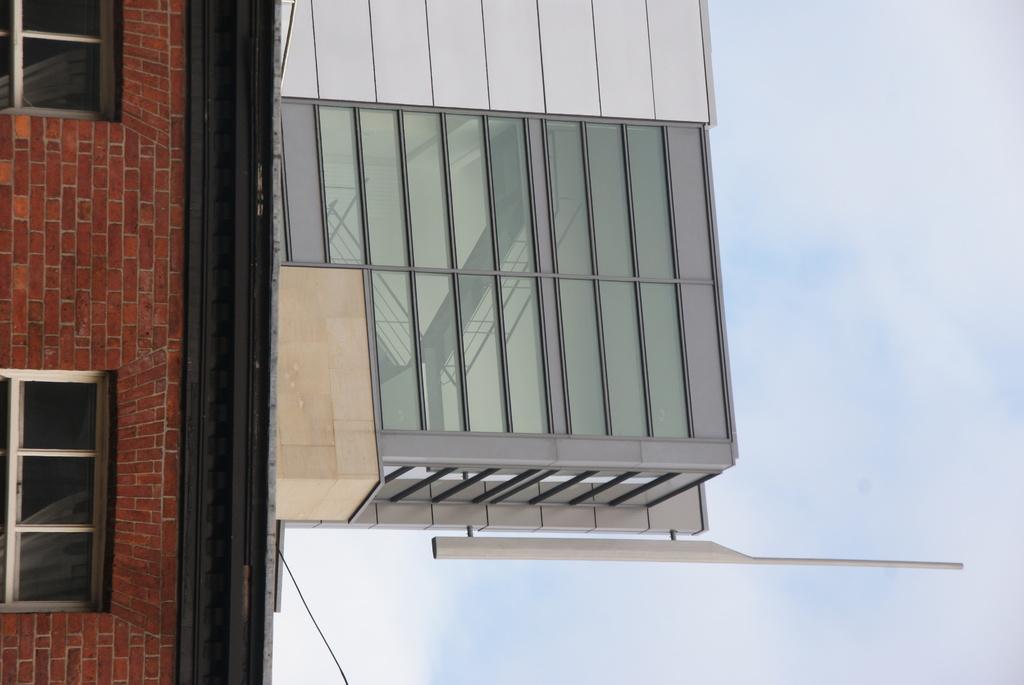In one or two sentences, can you explain what this image depicts? In this image I can see a building, two windows and a wire. On the right side of this image I can see clouds and the sky. 